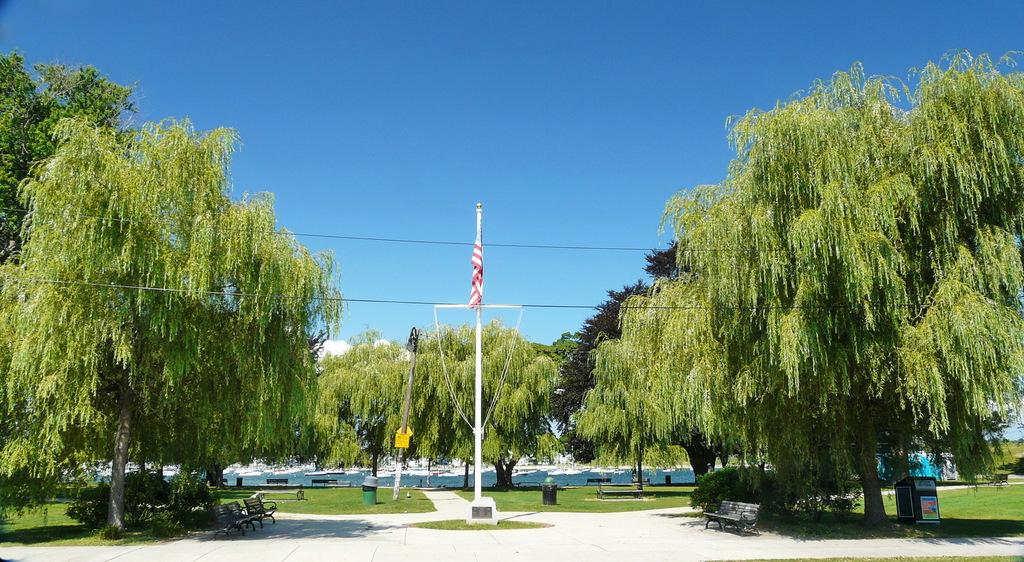What can be seen running through the area in the image? There is a path in the image. What is positioned between the path? There is a flag between the path. What type of natural elements surround the path? There are trees around the path. What disease is being treated by the flag in the image? There is no indication of a disease or treatment in the image; it simply features a path with a flag between it and trees surrounding the area. 